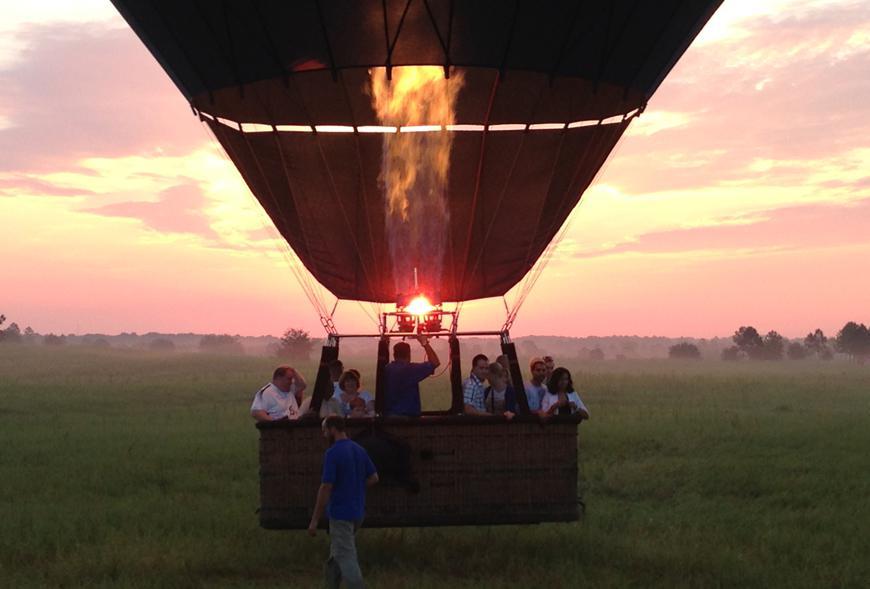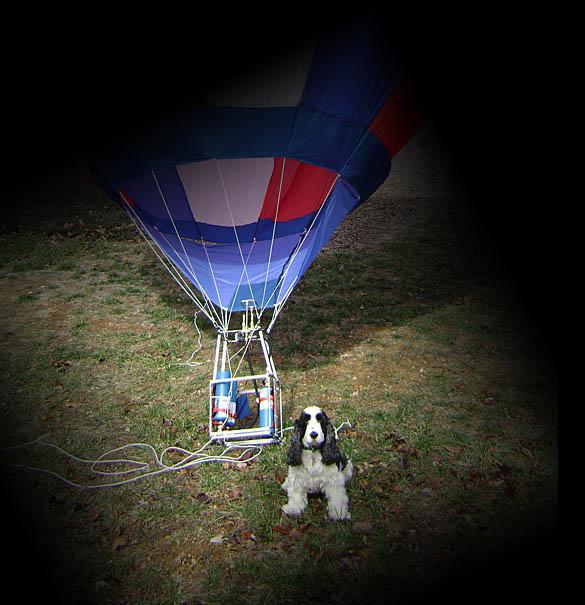The first image is the image on the left, the second image is the image on the right. For the images shown, is this caption "Both images show people in hot air balloon baskets floating in midair." true? Answer yes or no. No. The first image is the image on the left, the second image is the image on the right. Given the left and right images, does the statement "An image shows a person standing on the ground in a field with hot air balloon." hold true? Answer yes or no. Yes. 